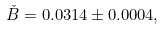Convert formula to latex. <formula><loc_0><loc_0><loc_500><loc_500>\check { B } = 0 . 0 3 1 4 \pm 0 . 0 0 0 4 ,</formula> 